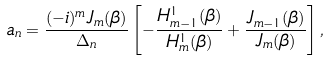<formula> <loc_0><loc_0><loc_500><loc_500>a _ { n } = \frac { ( - i ) ^ { m } J _ { m } ( \beta ) } { \Delta _ { n } } \left [ - \frac { H _ { m - 1 } ^ { 1 } ( \beta ) } { H _ { m } ^ { 1 } ( \beta ) } + \frac { J _ { m - 1 } ( \beta ) } { J _ { m } ( \beta ) } \right ] ,</formula> 